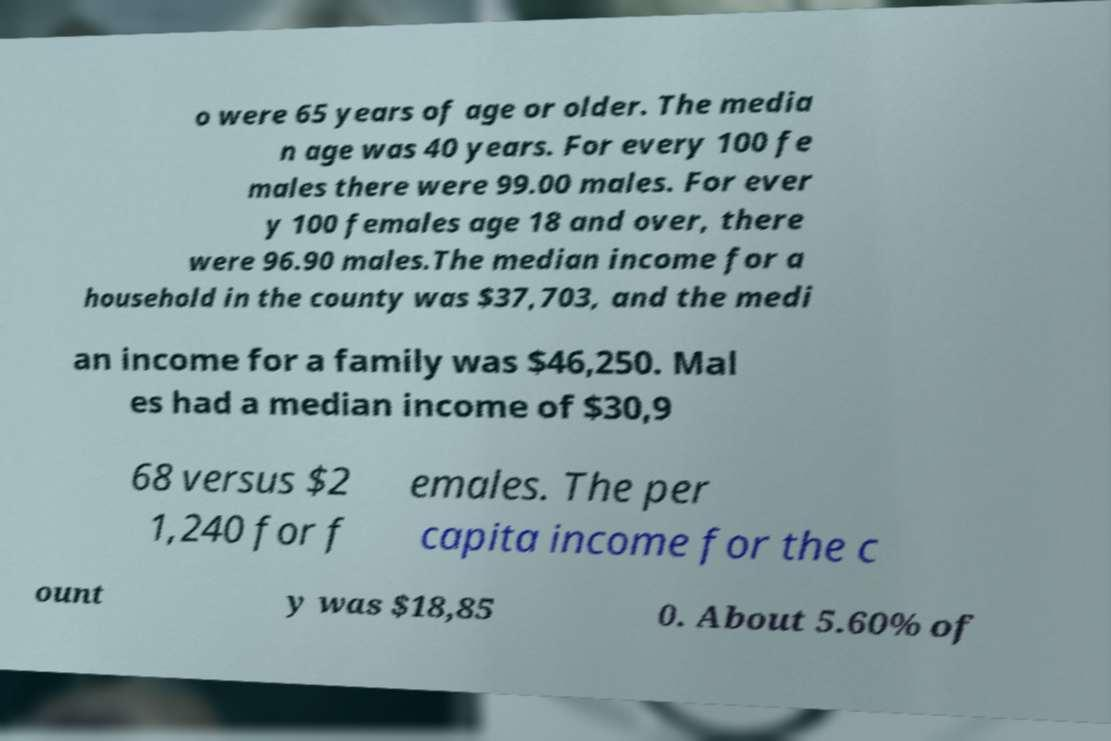There's text embedded in this image that I need extracted. Can you transcribe it verbatim? o were 65 years of age or older. The media n age was 40 years. For every 100 fe males there were 99.00 males. For ever y 100 females age 18 and over, there were 96.90 males.The median income for a household in the county was $37,703, and the medi an income for a family was $46,250. Mal es had a median income of $30,9 68 versus $2 1,240 for f emales. The per capita income for the c ount y was $18,85 0. About 5.60% of 